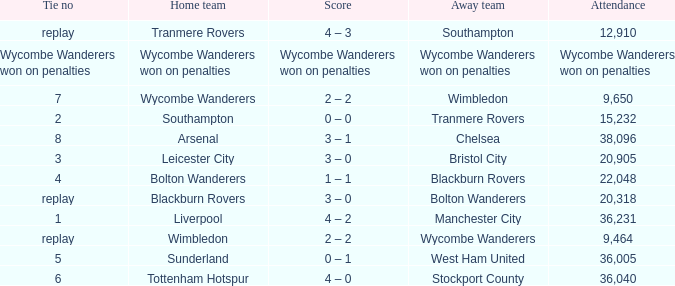What was the score for the game where the home team was Wycombe Wanderers? 2 – 2. 